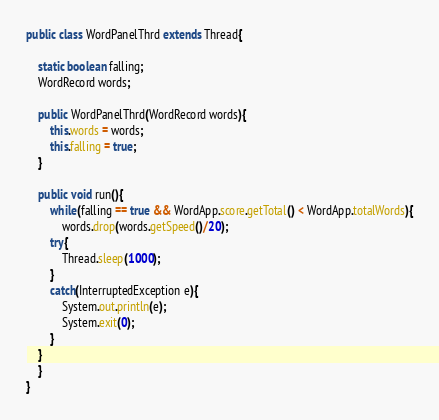Convert code to text. <code><loc_0><loc_0><loc_500><loc_500><_Java_>public class WordPanelThrd extends Thread{
	
	static boolean falling;
    WordRecord words;
    
    public WordPanelThrd(WordRecord words){
		this.words = words;
		this.falling = true;
	}
	
	public void run(){
		while(falling == true && WordApp.score.getTotal() < WordApp.totalWords){
			words.drop(words.getSpeed()/20);
		try{
			Thread.sleep(1000);
		}
		catch(InterruptedException e){
			System.out.println(e);
			System.exit(0);
		}
	}
	}
}
</code> 